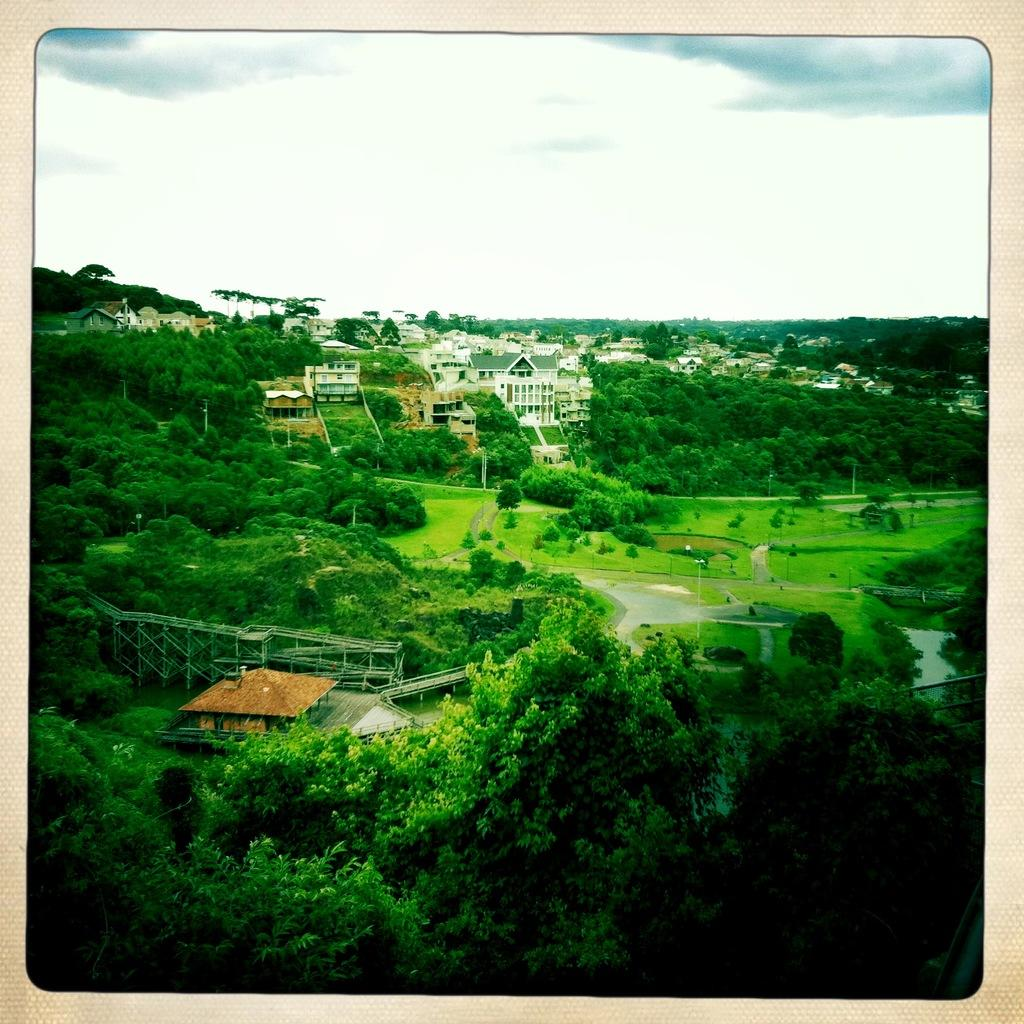What type of natural elements can be seen in the image? There are trees and plants in the image. What type of structures are visible in the image? There are houses, buildings, and huts in the image. What type of jam is being spread on the hut in the image? There is no jam or any indication of spreading in the image; it features trees, plants, houses, buildings, and huts. 